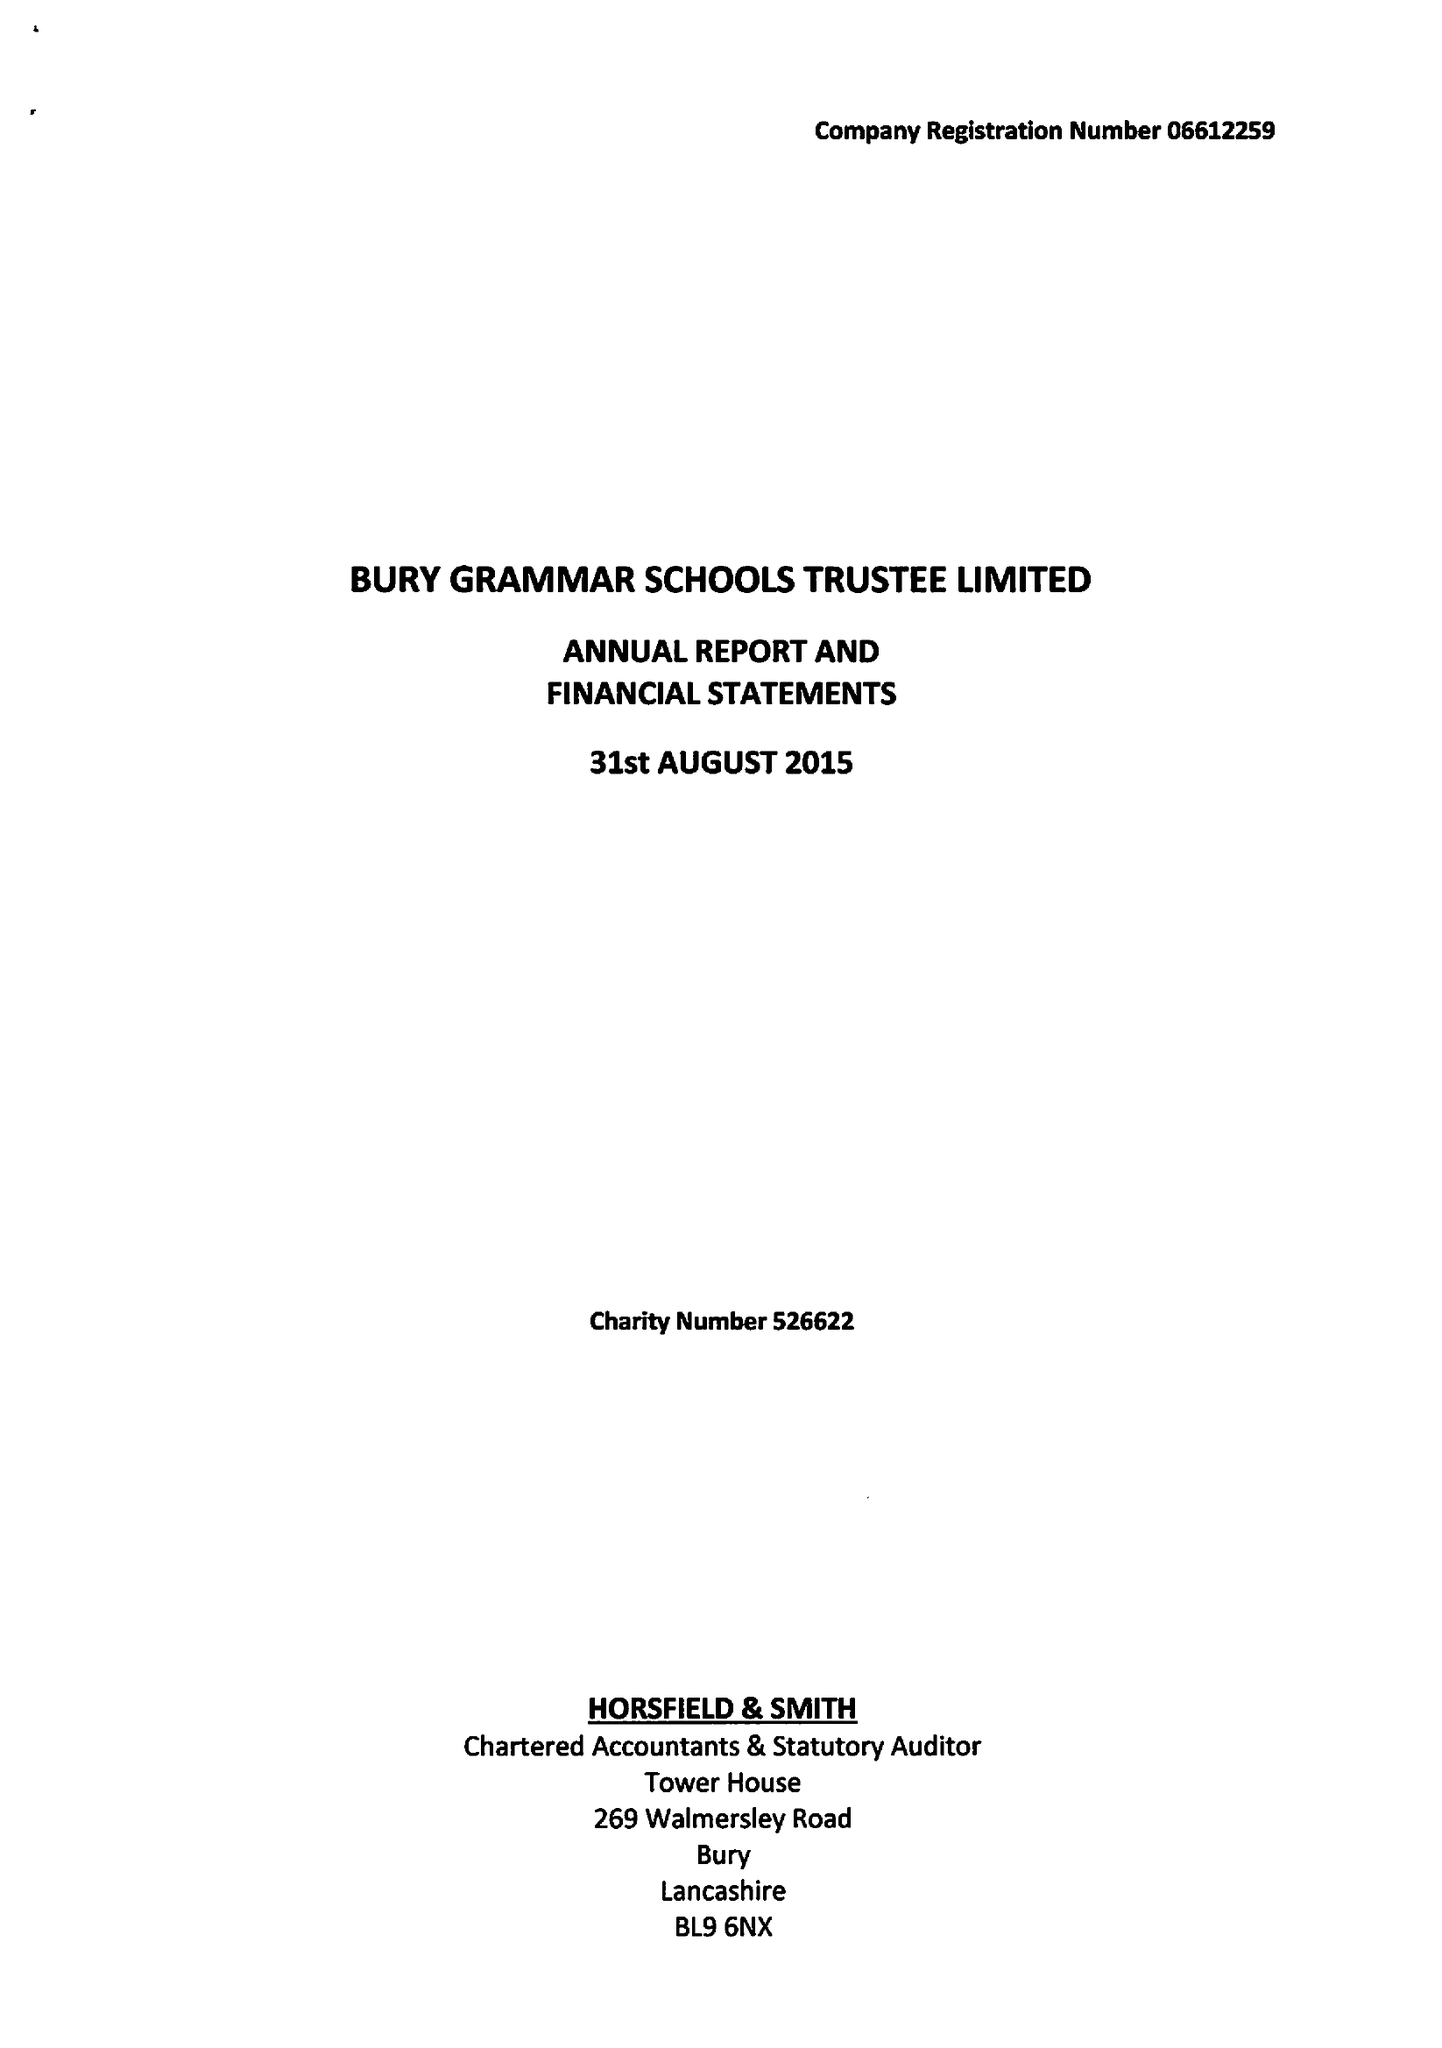What is the value for the charity_number?
Answer the question using a single word or phrase. 526622 